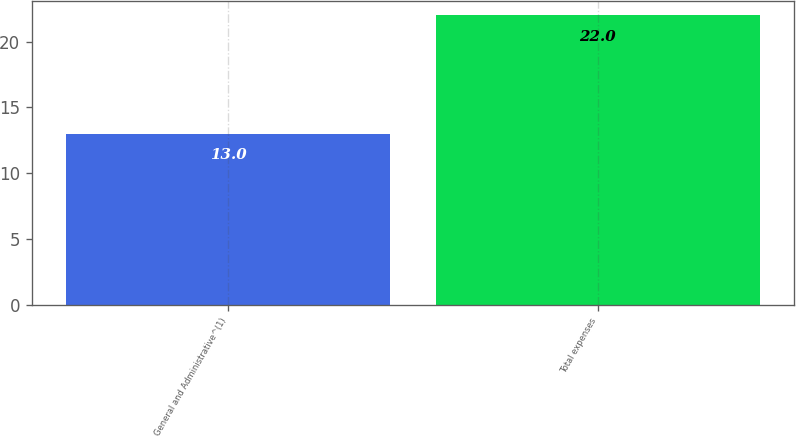Convert chart to OTSL. <chart><loc_0><loc_0><loc_500><loc_500><bar_chart><fcel>General and Administrative^(1)<fcel>Total expenses<nl><fcel>13<fcel>22<nl></chart> 